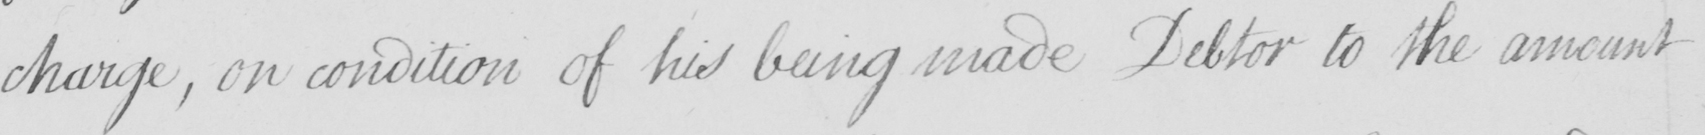Transcribe the text shown in this historical manuscript line. charge , on condition of his being made Debtor to the amount 